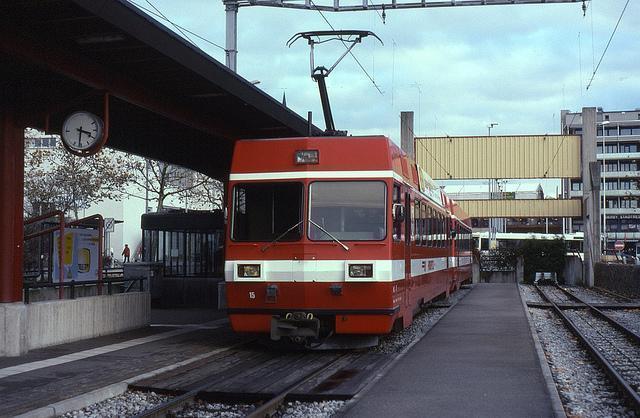How many hours until midnight?
Indicate the correct choice and explain in the format: 'Answer: answer
Rationale: rationale.'
Options: Two, three, four, eight. Answer: eight.
Rationale: The clock at the train station says it is 3:30 and about 8 hours until midnight. 